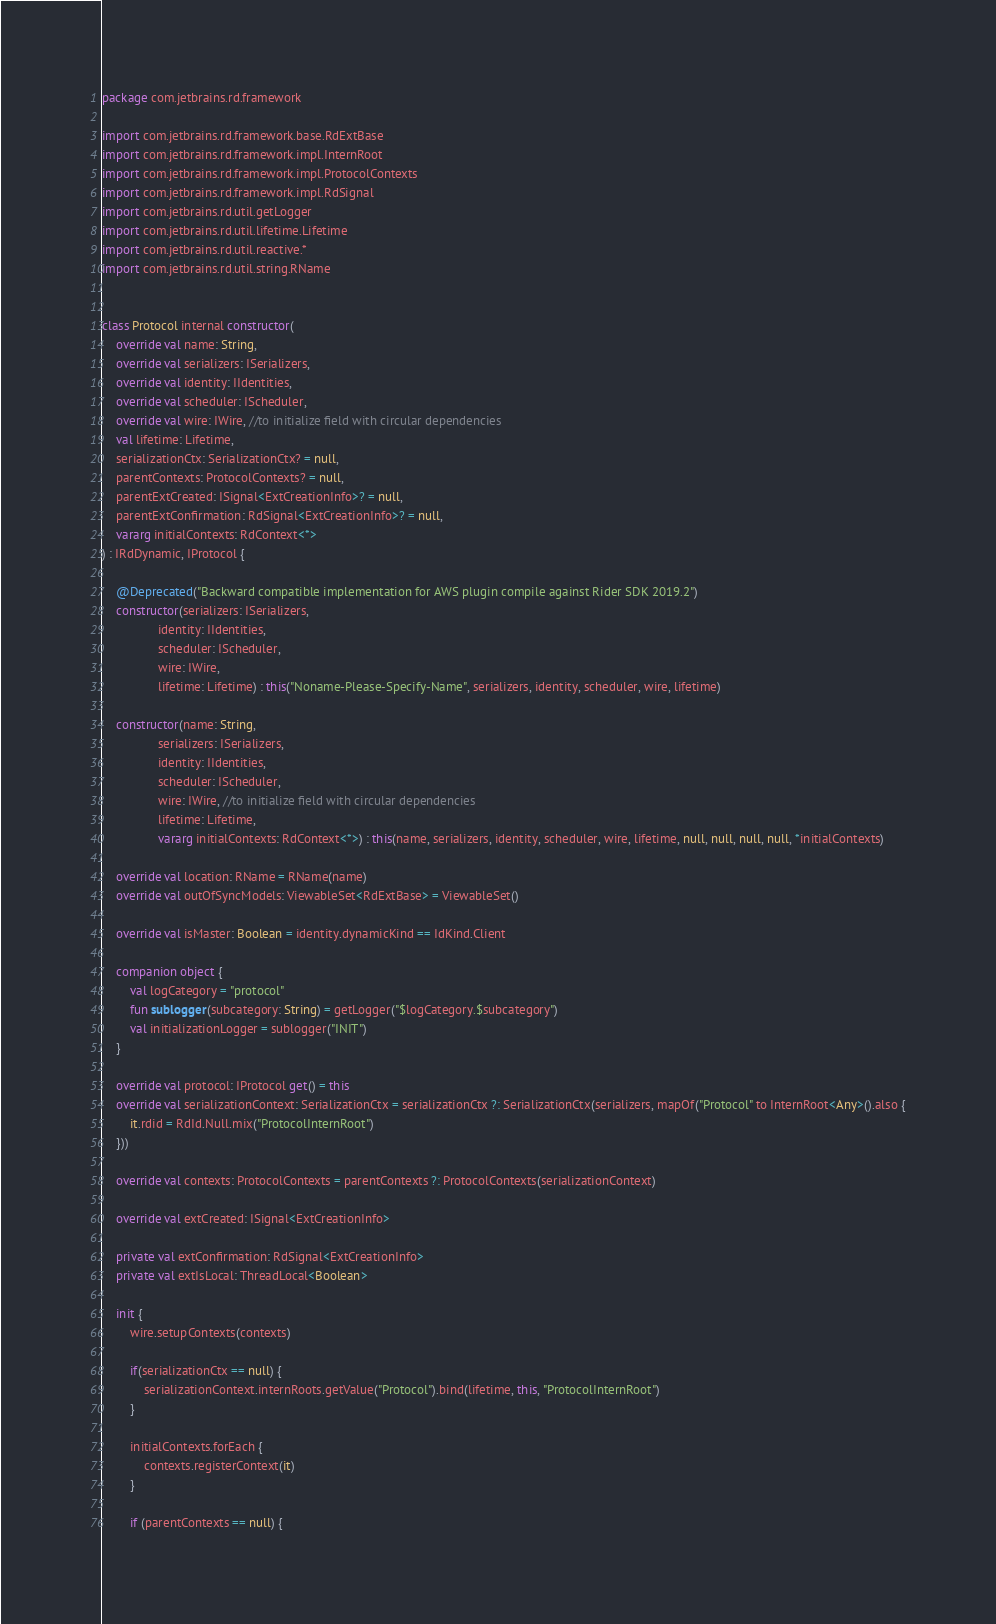<code> <loc_0><loc_0><loc_500><loc_500><_Kotlin_>package com.jetbrains.rd.framework

import com.jetbrains.rd.framework.base.RdExtBase
import com.jetbrains.rd.framework.impl.InternRoot
import com.jetbrains.rd.framework.impl.ProtocolContexts
import com.jetbrains.rd.framework.impl.RdSignal
import com.jetbrains.rd.util.getLogger
import com.jetbrains.rd.util.lifetime.Lifetime
import com.jetbrains.rd.util.reactive.*
import com.jetbrains.rd.util.string.RName


class Protocol internal constructor(
    override val name: String,
    override val serializers: ISerializers,
    override val identity: IIdentities,
    override val scheduler: IScheduler,
    override val wire: IWire, //to initialize field with circular dependencies
    val lifetime: Lifetime,
    serializationCtx: SerializationCtx? = null,
    parentContexts: ProtocolContexts? = null,
    parentExtCreated: ISignal<ExtCreationInfo>? = null,
    parentExtConfirmation: RdSignal<ExtCreationInfo>? = null,
    vararg initialContexts: RdContext<*>
) : IRdDynamic, IProtocol {

    @Deprecated("Backward compatible implementation for AWS plugin compile against Rider SDK 2019.2")
    constructor(serializers: ISerializers,
                identity: IIdentities,
                scheduler: IScheduler,
                wire: IWire,
                lifetime: Lifetime) : this("Noname-Please-Specify-Name", serializers, identity, scheduler, wire, lifetime)

    constructor(name: String,
                serializers: ISerializers,
                identity: IIdentities,
                scheduler: IScheduler,
                wire: IWire, //to initialize field with circular dependencies
                lifetime: Lifetime,
                vararg initialContexts: RdContext<*>) : this(name, serializers, identity, scheduler, wire, lifetime, null, null, null, null, *initialContexts)

    override val location: RName = RName(name)
    override val outOfSyncModels: ViewableSet<RdExtBase> = ViewableSet()

    override val isMaster: Boolean = identity.dynamicKind == IdKind.Client

    companion object {
        val logCategory = "protocol"
        fun sublogger(subcategory: String) = getLogger("$logCategory.$subcategory")
        val initializationLogger = sublogger("INIT")
    }

    override val protocol: IProtocol get() = this
    override val serializationContext: SerializationCtx = serializationCtx ?: SerializationCtx(serializers, mapOf("Protocol" to InternRoot<Any>().also {
        it.rdid = RdId.Null.mix("ProtocolInternRoot")
    }))

    override val contexts: ProtocolContexts = parentContexts ?: ProtocolContexts(serializationContext)

    override val extCreated: ISignal<ExtCreationInfo>

    private val extConfirmation: RdSignal<ExtCreationInfo>
    private val extIsLocal: ThreadLocal<Boolean>

    init {
        wire.setupContexts(contexts)

        if(serializationCtx == null) {
            serializationContext.internRoots.getValue("Protocol").bind(lifetime, this, "ProtocolInternRoot")
        }

        initialContexts.forEach {
            contexts.registerContext(it)
        }

        if (parentContexts == null) {</code> 